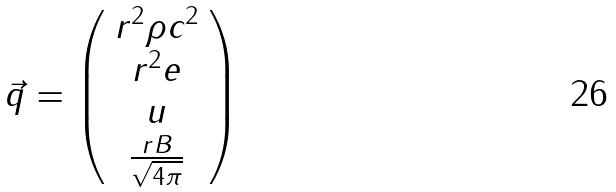<formula> <loc_0><loc_0><loc_500><loc_500>\vec { q } = \left ( \begin{array} { c } r ^ { 2 } \rho c ^ { 2 } \\ r ^ { 2 } e \\ u \\ \frac { r B } { \sqrt { 4 \pi } } \end{array} \right )</formula> 